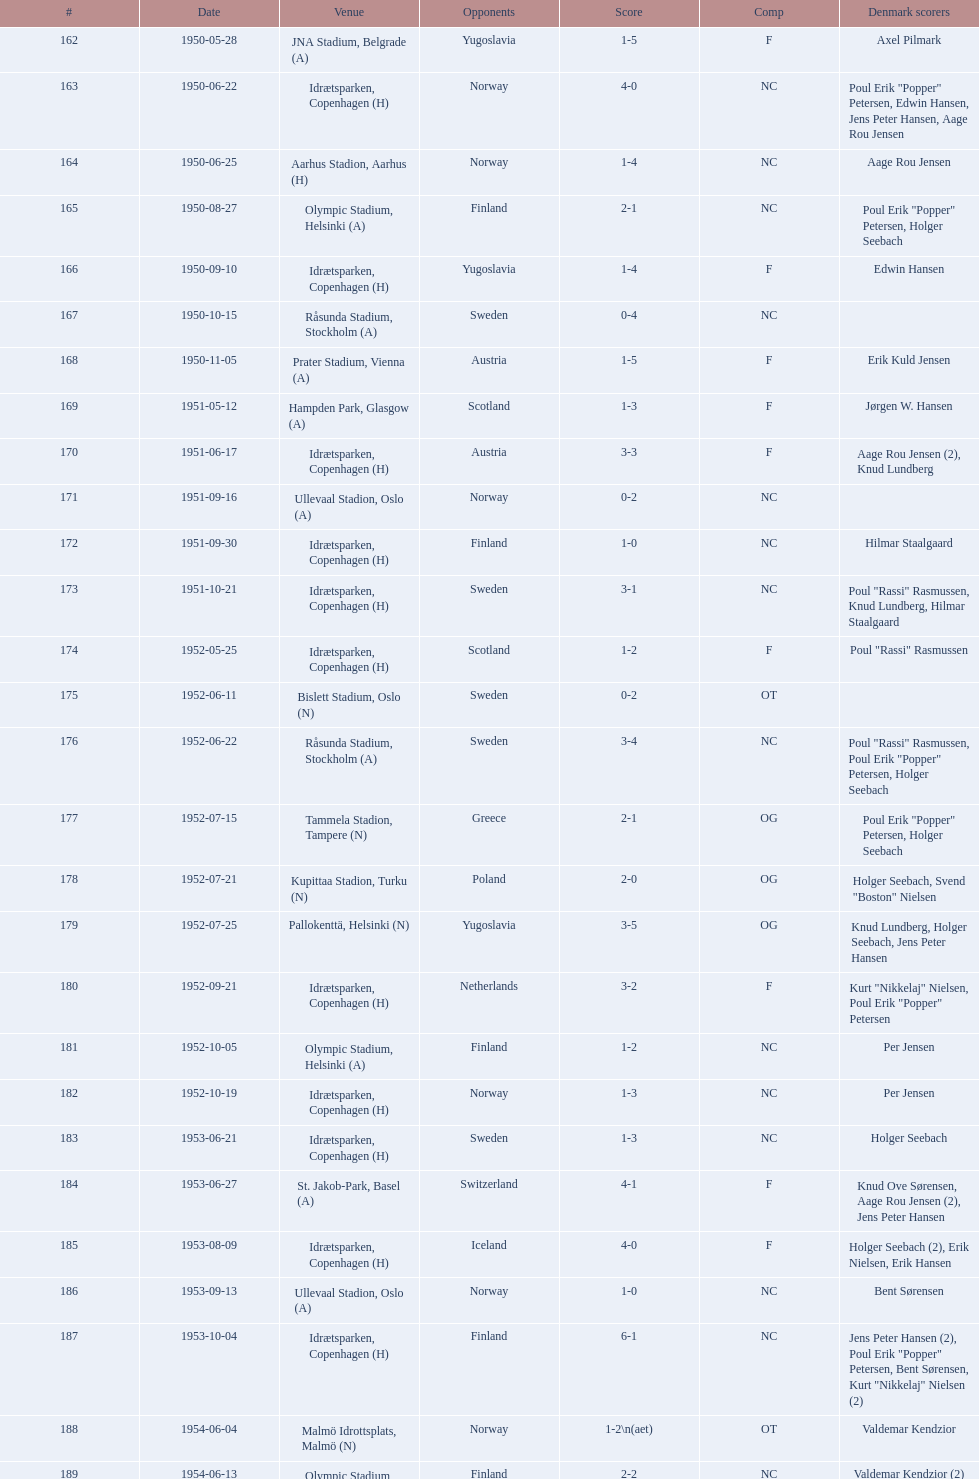Which total score was higher, game #163 or #181? 163. 